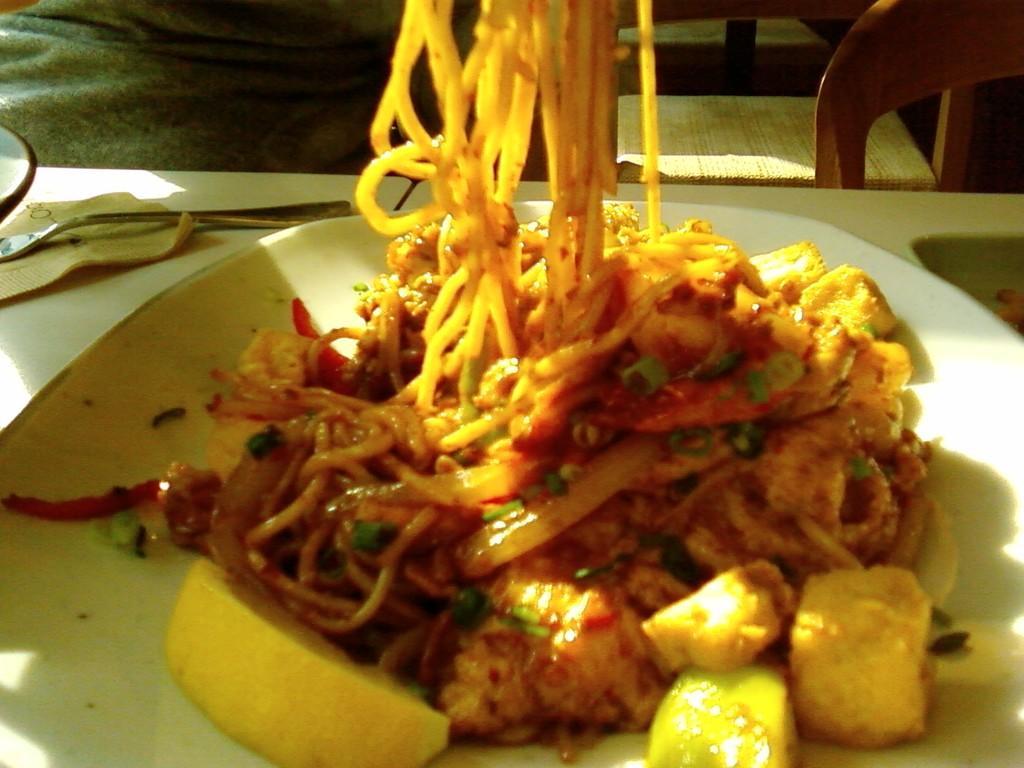Describe this image in one or two sentences. As we can see in the image there is a person, chair and table. On table there is a plate and fork. In plate there are noodles. 